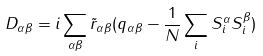<formula> <loc_0><loc_0><loc_500><loc_500>D _ { \alpha \beta } = i \sum _ { \alpha \beta } { \tilde { r } } _ { \alpha \beta } ( q _ { \alpha \beta } - \frac { 1 } { N } \sum _ { i } S _ { i } ^ { \alpha } S _ { i } ^ { \beta } )</formula> 